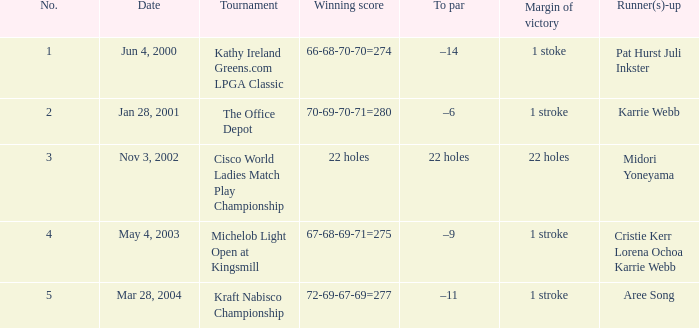Where was the tournament dated nov 3, 2002? Cisco World Ladies Match Play Championship. 